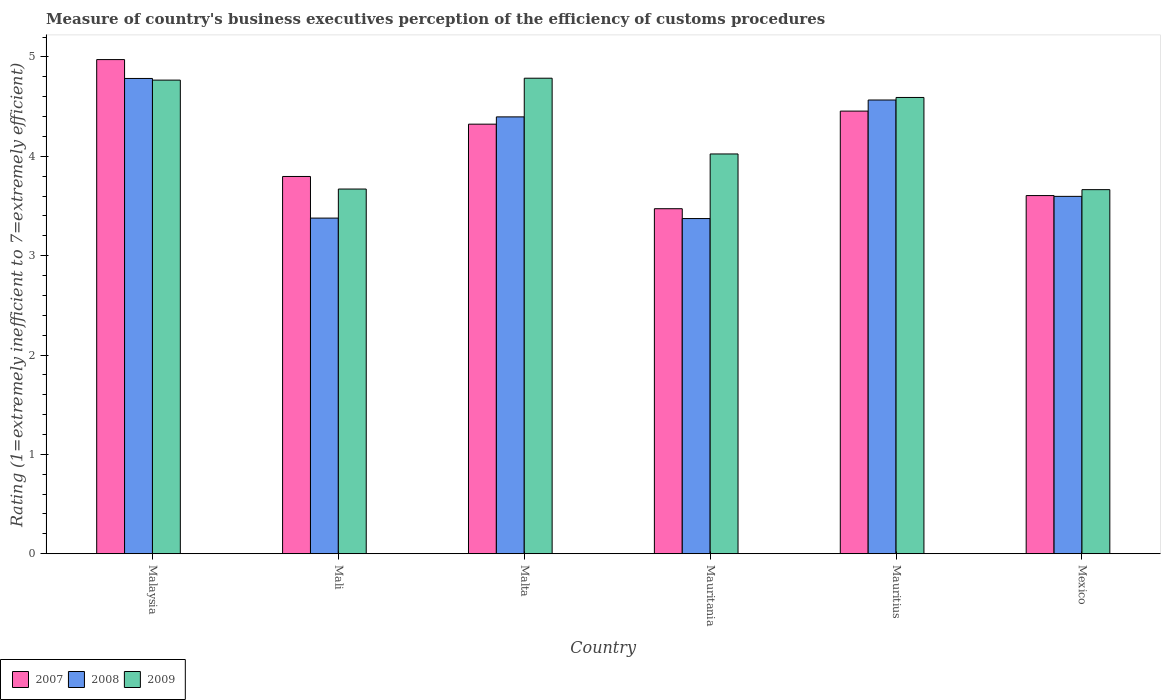How many different coloured bars are there?
Provide a succinct answer. 3. Are the number of bars per tick equal to the number of legend labels?
Your answer should be very brief. Yes. How many bars are there on the 3rd tick from the right?
Your answer should be very brief. 3. In how many cases, is the number of bars for a given country not equal to the number of legend labels?
Keep it short and to the point. 0. What is the rating of the efficiency of customs procedure in 2009 in Mali?
Your answer should be very brief. 3.67. Across all countries, what is the maximum rating of the efficiency of customs procedure in 2009?
Ensure brevity in your answer.  4.79. Across all countries, what is the minimum rating of the efficiency of customs procedure in 2009?
Keep it short and to the point. 3.66. In which country was the rating of the efficiency of customs procedure in 2009 maximum?
Make the answer very short. Malta. What is the total rating of the efficiency of customs procedure in 2009 in the graph?
Provide a succinct answer. 25.5. What is the difference between the rating of the efficiency of customs procedure in 2007 in Mali and that in Mauritania?
Ensure brevity in your answer.  0.32. What is the difference between the rating of the efficiency of customs procedure in 2007 in Malaysia and the rating of the efficiency of customs procedure in 2009 in Mauritius?
Your answer should be compact. 0.38. What is the average rating of the efficiency of customs procedure in 2007 per country?
Make the answer very short. 4.1. What is the difference between the rating of the efficiency of customs procedure of/in 2008 and rating of the efficiency of customs procedure of/in 2009 in Malaysia?
Your answer should be very brief. 0.02. What is the ratio of the rating of the efficiency of customs procedure in 2008 in Malaysia to that in Mexico?
Offer a terse response. 1.33. Is the difference between the rating of the efficiency of customs procedure in 2008 in Mauritania and Mauritius greater than the difference between the rating of the efficiency of customs procedure in 2009 in Mauritania and Mauritius?
Your answer should be compact. No. What is the difference between the highest and the second highest rating of the efficiency of customs procedure in 2008?
Provide a short and direct response. 0.22. What is the difference between the highest and the lowest rating of the efficiency of customs procedure in 2007?
Your response must be concise. 1.5. What does the 2nd bar from the right in Mauritius represents?
Your response must be concise. 2008. What is the difference between two consecutive major ticks on the Y-axis?
Ensure brevity in your answer.  1. Does the graph contain any zero values?
Make the answer very short. No. Does the graph contain grids?
Give a very brief answer. No. Where does the legend appear in the graph?
Provide a short and direct response. Bottom left. How many legend labels are there?
Offer a very short reply. 3. What is the title of the graph?
Make the answer very short. Measure of country's business executives perception of the efficiency of customs procedures. Does "2010" appear as one of the legend labels in the graph?
Keep it short and to the point. No. What is the label or title of the Y-axis?
Provide a short and direct response. Rating (1=extremely inefficient to 7=extremely efficient). What is the Rating (1=extremely inefficient to 7=extremely efficient) of 2007 in Malaysia?
Your response must be concise. 4.97. What is the Rating (1=extremely inefficient to 7=extremely efficient) in 2008 in Malaysia?
Your response must be concise. 4.78. What is the Rating (1=extremely inefficient to 7=extremely efficient) in 2009 in Malaysia?
Offer a terse response. 4.77. What is the Rating (1=extremely inefficient to 7=extremely efficient) in 2007 in Mali?
Your answer should be very brief. 3.8. What is the Rating (1=extremely inefficient to 7=extremely efficient) in 2008 in Mali?
Provide a short and direct response. 3.38. What is the Rating (1=extremely inefficient to 7=extremely efficient) in 2009 in Mali?
Keep it short and to the point. 3.67. What is the Rating (1=extremely inefficient to 7=extremely efficient) of 2007 in Malta?
Your answer should be compact. 4.32. What is the Rating (1=extremely inefficient to 7=extremely efficient) of 2008 in Malta?
Offer a terse response. 4.4. What is the Rating (1=extremely inefficient to 7=extremely efficient) of 2009 in Malta?
Your answer should be compact. 4.79. What is the Rating (1=extremely inefficient to 7=extremely efficient) of 2007 in Mauritania?
Your answer should be compact. 3.47. What is the Rating (1=extremely inefficient to 7=extremely efficient) in 2008 in Mauritania?
Make the answer very short. 3.37. What is the Rating (1=extremely inefficient to 7=extremely efficient) of 2009 in Mauritania?
Your answer should be compact. 4.02. What is the Rating (1=extremely inefficient to 7=extremely efficient) in 2007 in Mauritius?
Offer a very short reply. 4.45. What is the Rating (1=extremely inefficient to 7=extremely efficient) of 2008 in Mauritius?
Give a very brief answer. 4.57. What is the Rating (1=extremely inefficient to 7=extremely efficient) in 2009 in Mauritius?
Your answer should be very brief. 4.59. What is the Rating (1=extremely inefficient to 7=extremely efficient) in 2007 in Mexico?
Your response must be concise. 3.6. What is the Rating (1=extremely inefficient to 7=extremely efficient) of 2008 in Mexico?
Your answer should be very brief. 3.6. What is the Rating (1=extremely inefficient to 7=extremely efficient) of 2009 in Mexico?
Provide a short and direct response. 3.66. Across all countries, what is the maximum Rating (1=extremely inefficient to 7=extremely efficient) in 2007?
Ensure brevity in your answer.  4.97. Across all countries, what is the maximum Rating (1=extremely inefficient to 7=extremely efficient) in 2008?
Keep it short and to the point. 4.78. Across all countries, what is the maximum Rating (1=extremely inefficient to 7=extremely efficient) of 2009?
Provide a succinct answer. 4.79. Across all countries, what is the minimum Rating (1=extremely inefficient to 7=extremely efficient) of 2007?
Offer a terse response. 3.47. Across all countries, what is the minimum Rating (1=extremely inefficient to 7=extremely efficient) in 2008?
Offer a terse response. 3.37. Across all countries, what is the minimum Rating (1=extremely inefficient to 7=extremely efficient) in 2009?
Ensure brevity in your answer.  3.66. What is the total Rating (1=extremely inefficient to 7=extremely efficient) of 2007 in the graph?
Your answer should be compact. 24.62. What is the total Rating (1=extremely inefficient to 7=extremely efficient) of 2008 in the graph?
Keep it short and to the point. 24.09. What is the total Rating (1=extremely inefficient to 7=extremely efficient) of 2009 in the graph?
Ensure brevity in your answer.  25.5. What is the difference between the Rating (1=extremely inefficient to 7=extremely efficient) of 2007 in Malaysia and that in Mali?
Your answer should be very brief. 1.18. What is the difference between the Rating (1=extremely inefficient to 7=extremely efficient) in 2008 in Malaysia and that in Mali?
Provide a short and direct response. 1.41. What is the difference between the Rating (1=extremely inefficient to 7=extremely efficient) in 2009 in Malaysia and that in Mali?
Offer a terse response. 1.1. What is the difference between the Rating (1=extremely inefficient to 7=extremely efficient) of 2007 in Malaysia and that in Malta?
Your answer should be compact. 0.65. What is the difference between the Rating (1=extremely inefficient to 7=extremely efficient) in 2008 in Malaysia and that in Malta?
Offer a very short reply. 0.39. What is the difference between the Rating (1=extremely inefficient to 7=extremely efficient) of 2009 in Malaysia and that in Malta?
Provide a short and direct response. -0.02. What is the difference between the Rating (1=extremely inefficient to 7=extremely efficient) of 2007 in Malaysia and that in Mauritania?
Offer a very short reply. 1.5. What is the difference between the Rating (1=extremely inefficient to 7=extremely efficient) in 2008 in Malaysia and that in Mauritania?
Your response must be concise. 1.41. What is the difference between the Rating (1=extremely inefficient to 7=extremely efficient) of 2009 in Malaysia and that in Mauritania?
Ensure brevity in your answer.  0.74. What is the difference between the Rating (1=extremely inefficient to 7=extremely efficient) of 2007 in Malaysia and that in Mauritius?
Provide a succinct answer. 0.52. What is the difference between the Rating (1=extremely inefficient to 7=extremely efficient) in 2008 in Malaysia and that in Mauritius?
Provide a short and direct response. 0.22. What is the difference between the Rating (1=extremely inefficient to 7=extremely efficient) in 2009 in Malaysia and that in Mauritius?
Offer a terse response. 0.17. What is the difference between the Rating (1=extremely inefficient to 7=extremely efficient) in 2007 in Malaysia and that in Mexico?
Provide a short and direct response. 1.37. What is the difference between the Rating (1=extremely inefficient to 7=extremely efficient) of 2008 in Malaysia and that in Mexico?
Provide a succinct answer. 1.19. What is the difference between the Rating (1=extremely inefficient to 7=extremely efficient) in 2009 in Malaysia and that in Mexico?
Offer a very short reply. 1.1. What is the difference between the Rating (1=extremely inefficient to 7=extremely efficient) of 2007 in Mali and that in Malta?
Keep it short and to the point. -0.53. What is the difference between the Rating (1=extremely inefficient to 7=extremely efficient) of 2008 in Mali and that in Malta?
Offer a very short reply. -1.02. What is the difference between the Rating (1=extremely inefficient to 7=extremely efficient) of 2009 in Mali and that in Malta?
Offer a very short reply. -1.12. What is the difference between the Rating (1=extremely inefficient to 7=extremely efficient) of 2007 in Mali and that in Mauritania?
Offer a very short reply. 0.32. What is the difference between the Rating (1=extremely inefficient to 7=extremely efficient) of 2008 in Mali and that in Mauritania?
Provide a short and direct response. 0. What is the difference between the Rating (1=extremely inefficient to 7=extremely efficient) of 2009 in Mali and that in Mauritania?
Your answer should be compact. -0.35. What is the difference between the Rating (1=extremely inefficient to 7=extremely efficient) in 2007 in Mali and that in Mauritius?
Your response must be concise. -0.66. What is the difference between the Rating (1=extremely inefficient to 7=extremely efficient) of 2008 in Mali and that in Mauritius?
Make the answer very short. -1.19. What is the difference between the Rating (1=extremely inefficient to 7=extremely efficient) in 2009 in Mali and that in Mauritius?
Provide a succinct answer. -0.92. What is the difference between the Rating (1=extremely inefficient to 7=extremely efficient) in 2007 in Mali and that in Mexico?
Your response must be concise. 0.19. What is the difference between the Rating (1=extremely inefficient to 7=extremely efficient) of 2008 in Mali and that in Mexico?
Give a very brief answer. -0.22. What is the difference between the Rating (1=extremely inefficient to 7=extremely efficient) in 2009 in Mali and that in Mexico?
Provide a succinct answer. 0.01. What is the difference between the Rating (1=extremely inefficient to 7=extremely efficient) of 2007 in Malta and that in Mauritania?
Ensure brevity in your answer.  0.85. What is the difference between the Rating (1=extremely inefficient to 7=extremely efficient) in 2008 in Malta and that in Mauritania?
Your answer should be compact. 1.02. What is the difference between the Rating (1=extremely inefficient to 7=extremely efficient) of 2009 in Malta and that in Mauritania?
Provide a succinct answer. 0.76. What is the difference between the Rating (1=extremely inefficient to 7=extremely efficient) in 2007 in Malta and that in Mauritius?
Give a very brief answer. -0.13. What is the difference between the Rating (1=extremely inefficient to 7=extremely efficient) of 2008 in Malta and that in Mauritius?
Your answer should be compact. -0.17. What is the difference between the Rating (1=extremely inefficient to 7=extremely efficient) of 2009 in Malta and that in Mauritius?
Provide a succinct answer. 0.19. What is the difference between the Rating (1=extremely inefficient to 7=extremely efficient) of 2007 in Malta and that in Mexico?
Make the answer very short. 0.72. What is the difference between the Rating (1=extremely inefficient to 7=extremely efficient) in 2008 in Malta and that in Mexico?
Make the answer very short. 0.8. What is the difference between the Rating (1=extremely inefficient to 7=extremely efficient) in 2009 in Malta and that in Mexico?
Offer a very short reply. 1.12. What is the difference between the Rating (1=extremely inefficient to 7=extremely efficient) in 2007 in Mauritania and that in Mauritius?
Offer a terse response. -0.98. What is the difference between the Rating (1=extremely inefficient to 7=extremely efficient) in 2008 in Mauritania and that in Mauritius?
Offer a terse response. -1.19. What is the difference between the Rating (1=extremely inefficient to 7=extremely efficient) in 2009 in Mauritania and that in Mauritius?
Keep it short and to the point. -0.57. What is the difference between the Rating (1=extremely inefficient to 7=extremely efficient) in 2007 in Mauritania and that in Mexico?
Provide a succinct answer. -0.13. What is the difference between the Rating (1=extremely inefficient to 7=extremely efficient) in 2008 in Mauritania and that in Mexico?
Your response must be concise. -0.22. What is the difference between the Rating (1=extremely inefficient to 7=extremely efficient) of 2009 in Mauritania and that in Mexico?
Provide a short and direct response. 0.36. What is the difference between the Rating (1=extremely inefficient to 7=extremely efficient) in 2007 in Mauritius and that in Mexico?
Keep it short and to the point. 0.85. What is the difference between the Rating (1=extremely inefficient to 7=extremely efficient) of 2008 in Mauritius and that in Mexico?
Offer a terse response. 0.97. What is the difference between the Rating (1=extremely inefficient to 7=extremely efficient) of 2009 in Mauritius and that in Mexico?
Make the answer very short. 0.93. What is the difference between the Rating (1=extremely inefficient to 7=extremely efficient) of 2007 in Malaysia and the Rating (1=extremely inefficient to 7=extremely efficient) of 2008 in Mali?
Offer a terse response. 1.6. What is the difference between the Rating (1=extremely inefficient to 7=extremely efficient) of 2007 in Malaysia and the Rating (1=extremely inefficient to 7=extremely efficient) of 2009 in Mali?
Your response must be concise. 1.3. What is the difference between the Rating (1=extremely inefficient to 7=extremely efficient) of 2008 in Malaysia and the Rating (1=extremely inefficient to 7=extremely efficient) of 2009 in Mali?
Your answer should be compact. 1.11. What is the difference between the Rating (1=extremely inefficient to 7=extremely efficient) of 2007 in Malaysia and the Rating (1=extremely inefficient to 7=extremely efficient) of 2008 in Malta?
Provide a short and direct response. 0.58. What is the difference between the Rating (1=extremely inefficient to 7=extremely efficient) of 2007 in Malaysia and the Rating (1=extremely inefficient to 7=extremely efficient) of 2009 in Malta?
Keep it short and to the point. 0.19. What is the difference between the Rating (1=extremely inefficient to 7=extremely efficient) in 2008 in Malaysia and the Rating (1=extremely inefficient to 7=extremely efficient) in 2009 in Malta?
Make the answer very short. -0. What is the difference between the Rating (1=extremely inefficient to 7=extremely efficient) of 2007 in Malaysia and the Rating (1=extremely inefficient to 7=extremely efficient) of 2008 in Mauritania?
Keep it short and to the point. 1.6. What is the difference between the Rating (1=extremely inefficient to 7=extremely efficient) of 2007 in Malaysia and the Rating (1=extremely inefficient to 7=extremely efficient) of 2009 in Mauritania?
Make the answer very short. 0.95. What is the difference between the Rating (1=extremely inefficient to 7=extremely efficient) in 2008 in Malaysia and the Rating (1=extremely inefficient to 7=extremely efficient) in 2009 in Mauritania?
Your answer should be very brief. 0.76. What is the difference between the Rating (1=extremely inefficient to 7=extremely efficient) of 2007 in Malaysia and the Rating (1=extremely inefficient to 7=extremely efficient) of 2008 in Mauritius?
Keep it short and to the point. 0.41. What is the difference between the Rating (1=extremely inefficient to 7=extremely efficient) in 2007 in Malaysia and the Rating (1=extremely inefficient to 7=extremely efficient) in 2009 in Mauritius?
Give a very brief answer. 0.38. What is the difference between the Rating (1=extremely inefficient to 7=extremely efficient) of 2008 in Malaysia and the Rating (1=extremely inefficient to 7=extremely efficient) of 2009 in Mauritius?
Keep it short and to the point. 0.19. What is the difference between the Rating (1=extremely inefficient to 7=extremely efficient) of 2007 in Malaysia and the Rating (1=extremely inefficient to 7=extremely efficient) of 2008 in Mexico?
Give a very brief answer. 1.38. What is the difference between the Rating (1=extremely inefficient to 7=extremely efficient) of 2007 in Malaysia and the Rating (1=extremely inefficient to 7=extremely efficient) of 2009 in Mexico?
Make the answer very short. 1.31. What is the difference between the Rating (1=extremely inefficient to 7=extremely efficient) in 2008 in Malaysia and the Rating (1=extremely inefficient to 7=extremely efficient) in 2009 in Mexico?
Keep it short and to the point. 1.12. What is the difference between the Rating (1=extremely inefficient to 7=extremely efficient) in 2007 in Mali and the Rating (1=extremely inefficient to 7=extremely efficient) in 2008 in Malta?
Offer a terse response. -0.6. What is the difference between the Rating (1=extremely inefficient to 7=extremely efficient) of 2007 in Mali and the Rating (1=extremely inefficient to 7=extremely efficient) of 2009 in Malta?
Keep it short and to the point. -0.99. What is the difference between the Rating (1=extremely inefficient to 7=extremely efficient) in 2008 in Mali and the Rating (1=extremely inefficient to 7=extremely efficient) in 2009 in Malta?
Provide a succinct answer. -1.41. What is the difference between the Rating (1=extremely inefficient to 7=extremely efficient) in 2007 in Mali and the Rating (1=extremely inefficient to 7=extremely efficient) in 2008 in Mauritania?
Offer a terse response. 0.42. What is the difference between the Rating (1=extremely inefficient to 7=extremely efficient) in 2007 in Mali and the Rating (1=extremely inefficient to 7=extremely efficient) in 2009 in Mauritania?
Offer a terse response. -0.23. What is the difference between the Rating (1=extremely inefficient to 7=extremely efficient) in 2008 in Mali and the Rating (1=extremely inefficient to 7=extremely efficient) in 2009 in Mauritania?
Offer a terse response. -0.65. What is the difference between the Rating (1=extremely inefficient to 7=extremely efficient) in 2007 in Mali and the Rating (1=extremely inefficient to 7=extremely efficient) in 2008 in Mauritius?
Provide a short and direct response. -0.77. What is the difference between the Rating (1=extremely inefficient to 7=extremely efficient) of 2007 in Mali and the Rating (1=extremely inefficient to 7=extremely efficient) of 2009 in Mauritius?
Make the answer very short. -0.8. What is the difference between the Rating (1=extremely inefficient to 7=extremely efficient) of 2008 in Mali and the Rating (1=extremely inefficient to 7=extremely efficient) of 2009 in Mauritius?
Make the answer very short. -1.21. What is the difference between the Rating (1=extremely inefficient to 7=extremely efficient) of 2007 in Mali and the Rating (1=extremely inefficient to 7=extremely efficient) of 2008 in Mexico?
Offer a very short reply. 0.2. What is the difference between the Rating (1=extremely inefficient to 7=extremely efficient) in 2007 in Mali and the Rating (1=extremely inefficient to 7=extremely efficient) in 2009 in Mexico?
Keep it short and to the point. 0.13. What is the difference between the Rating (1=extremely inefficient to 7=extremely efficient) in 2008 in Mali and the Rating (1=extremely inefficient to 7=extremely efficient) in 2009 in Mexico?
Your answer should be compact. -0.29. What is the difference between the Rating (1=extremely inefficient to 7=extremely efficient) in 2007 in Malta and the Rating (1=extremely inefficient to 7=extremely efficient) in 2008 in Mauritania?
Your answer should be compact. 0.95. What is the difference between the Rating (1=extremely inefficient to 7=extremely efficient) in 2007 in Malta and the Rating (1=extremely inefficient to 7=extremely efficient) in 2009 in Mauritania?
Offer a very short reply. 0.3. What is the difference between the Rating (1=extremely inefficient to 7=extremely efficient) in 2008 in Malta and the Rating (1=extremely inefficient to 7=extremely efficient) in 2009 in Mauritania?
Give a very brief answer. 0.37. What is the difference between the Rating (1=extremely inefficient to 7=extremely efficient) in 2007 in Malta and the Rating (1=extremely inefficient to 7=extremely efficient) in 2008 in Mauritius?
Your answer should be compact. -0.24. What is the difference between the Rating (1=extremely inefficient to 7=extremely efficient) of 2007 in Malta and the Rating (1=extremely inefficient to 7=extremely efficient) of 2009 in Mauritius?
Make the answer very short. -0.27. What is the difference between the Rating (1=extremely inefficient to 7=extremely efficient) of 2008 in Malta and the Rating (1=extremely inefficient to 7=extremely efficient) of 2009 in Mauritius?
Your answer should be compact. -0.2. What is the difference between the Rating (1=extremely inefficient to 7=extremely efficient) in 2007 in Malta and the Rating (1=extremely inefficient to 7=extremely efficient) in 2008 in Mexico?
Offer a very short reply. 0.73. What is the difference between the Rating (1=extremely inefficient to 7=extremely efficient) in 2007 in Malta and the Rating (1=extremely inefficient to 7=extremely efficient) in 2009 in Mexico?
Offer a very short reply. 0.66. What is the difference between the Rating (1=extremely inefficient to 7=extremely efficient) in 2008 in Malta and the Rating (1=extremely inefficient to 7=extremely efficient) in 2009 in Mexico?
Provide a succinct answer. 0.73. What is the difference between the Rating (1=extremely inefficient to 7=extremely efficient) of 2007 in Mauritania and the Rating (1=extremely inefficient to 7=extremely efficient) of 2008 in Mauritius?
Keep it short and to the point. -1.09. What is the difference between the Rating (1=extremely inefficient to 7=extremely efficient) in 2007 in Mauritania and the Rating (1=extremely inefficient to 7=extremely efficient) in 2009 in Mauritius?
Offer a very short reply. -1.12. What is the difference between the Rating (1=extremely inefficient to 7=extremely efficient) of 2008 in Mauritania and the Rating (1=extremely inefficient to 7=extremely efficient) of 2009 in Mauritius?
Your response must be concise. -1.22. What is the difference between the Rating (1=extremely inefficient to 7=extremely efficient) of 2007 in Mauritania and the Rating (1=extremely inefficient to 7=extremely efficient) of 2008 in Mexico?
Keep it short and to the point. -0.12. What is the difference between the Rating (1=extremely inefficient to 7=extremely efficient) in 2007 in Mauritania and the Rating (1=extremely inefficient to 7=extremely efficient) in 2009 in Mexico?
Ensure brevity in your answer.  -0.19. What is the difference between the Rating (1=extremely inefficient to 7=extremely efficient) of 2008 in Mauritania and the Rating (1=extremely inefficient to 7=extremely efficient) of 2009 in Mexico?
Your response must be concise. -0.29. What is the difference between the Rating (1=extremely inefficient to 7=extremely efficient) of 2007 in Mauritius and the Rating (1=extremely inefficient to 7=extremely efficient) of 2008 in Mexico?
Offer a terse response. 0.86. What is the difference between the Rating (1=extremely inefficient to 7=extremely efficient) of 2007 in Mauritius and the Rating (1=extremely inefficient to 7=extremely efficient) of 2009 in Mexico?
Offer a very short reply. 0.79. What is the difference between the Rating (1=extremely inefficient to 7=extremely efficient) of 2008 in Mauritius and the Rating (1=extremely inefficient to 7=extremely efficient) of 2009 in Mexico?
Make the answer very short. 0.9. What is the average Rating (1=extremely inefficient to 7=extremely efficient) in 2007 per country?
Offer a terse response. 4.1. What is the average Rating (1=extremely inefficient to 7=extremely efficient) in 2008 per country?
Make the answer very short. 4.02. What is the average Rating (1=extremely inefficient to 7=extremely efficient) in 2009 per country?
Keep it short and to the point. 4.25. What is the difference between the Rating (1=extremely inefficient to 7=extremely efficient) of 2007 and Rating (1=extremely inefficient to 7=extremely efficient) of 2008 in Malaysia?
Your answer should be compact. 0.19. What is the difference between the Rating (1=extremely inefficient to 7=extremely efficient) of 2007 and Rating (1=extremely inefficient to 7=extremely efficient) of 2009 in Malaysia?
Keep it short and to the point. 0.21. What is the difference between the Rating (1=extremely inefficient to 7=extremely efficient) of 2008 and Rating (1=extremely inefficient to 7=extremely efficient) of 2009 in Malaysia?
Your answer should be very brief. 0.02. What is the difference between the Rating (1=extremely inefficient to 7=extremely efficient) in 2007 and Rating (1=extremely inefficient to 7=extremely efficient) in 2008 in Mali?
Your answer should be compact. 0.42. What is the difference between the Rating (1=extremely inefficient to 7=extremely efficient) of 2007 and Rating (1=extremely inefficient to 7=extremely efficient) of 2009 in Mali?
Keep it short and to the point. 0.13. What is the difference between the Rating (1=extremely inefficient to 7=extremely efficient) in 2008 and Rating (1=extremely inefficient to 7=extremely efficient) in 2009 in Mali?
Your answer should be compact. -0.29. What is the difference between the Rating (1=extremely inefficient to 7=extremely efficient) in 2007 and Rating (1=extremely inefficient to 7=extremely efficient) in 2008 in Malta?
Provide a short and direct response. -0.07. What is the difference between the Rating (1=extremely inefficient to 7=extremely efficient) in 2007 and Rating (1=extremely inefficient to 7=extremely efficient) in 2009 in Malta?
Ensure brevity in your answer.  -0.46. What is the difference between the Rating (1=extremely inefficient to 7=extremely efficient) of 2008 and Rating (1=extremely inefficient to 7=extremely efficient) of 2009 in Malta?
Keep it short and to the point. -0.39. What is the difference between the Rating (1=extremely inefficient to 7=extremely efficient) of 2007 and Rating (1=extremely inefficient to 7=extremely efficient) of 2008 in Mauritania?
Make the answer very short. 0.1. What is the difference between the Rating (1=extremely inefficient to 7=extremely efficient) of 2007 and Rating (1=extremely inefficient to 7=extremely efficient) of 2009 in Mauritania?
Your answer should be compact. -0.55. What is the difference between the Rating (1=extremely inefficient to 7=extremely efficient) in 2008 and Rating (1=extremely inefficient to 7=extremely efficient) in 2009 in Mauritania?
Provide a succinct answer. -0.65. What is the difference between the Rating (1=extremely inefficient to 7=extremely efficient) in 2007 and Rating (1=extremely inefficient to 7=extremely efficient) in 2008 in Mauritius?
Your answer should be compact. -0.11. What is the difference between the Rating (1=extremely inefficient to 7=extremely efficient) of 2007 and Rating (1=extremely inefficient to 7=extremely efficient) of 2009 in Mauritius?
Provide a short and direct response. -0.14. What is the difference between the Rating (1=extremely inefficient to 7=extremely efficient) of 2008 and Rating (1=extremely inefficient to 7=extremely efficient) of 2009 in Mauritius?
Keep it short and to the point. -0.03. What is the difference between the Rating (1=extremely inefficient to 7=extremely efficient) of 2007 and Rating (1=extremely inefficient to 7=extremely efficient) of 2008 in Mexico?
Keep it short and to the point. 0.01. What is the difference between the Rating (1=extremely inefficient to 7=extremely efficient) in 2007 and Rating (1=extremely inefficient to 7=extremely efficient) in 2009 in Mexico?
Ensure brevity in your answer.  -0.06. What is the difference between the Rating (1=extremely inefficient to 7=extremely efficient) of 2008 and Rating (1=extremely inefficient to 7=extremely efficient) of 2009 in Mexico?
Your answer should be compact. -0.07. What is the ratio of the Rating (1=extremely inefficient to 7=extremely efficient) in 2007 in Malaysia to that in Mali?
Offer a very short reply. 1.31. What is the ratio of the Rating (1=extremely inefficient to 7=extremely efficient) in 2008 in Malaysia to that in Mali?
Ensure brevity in your answer.  1.42. What is the ratio of the Rating (1=extremely inefficient to 7=extremely efficient) in 2009 in Malaysia to that in Mali?
Provide a succinct answer. 1.3. What is the ratio of the Rating (1=extremely inefficient to 7=extremely efficient) of 2007 in Malaysia to that in Malta?
Your answer should be very brief. 1.15. What is the ratio of the Rating (1=extremely inefficient to 7=extremely efficient) of 2008 in Malaysia to that in Malta?
Provide a short and direct response. 1.09. What is the ratio of the Rating (1=extremely inefficient to 7=extremely efficient) of 2007 in Malaysia to that in Mauritania?
Your answer should be compact. 1.43. What is the ratio of the Rating (1=extremely inefficient to 7=extremely efficient) of 2008 in Malaysia to that in Mauritania?
Provide a succinct answer. 1.42. What is the ratio of the Rating (1=extremely inefficient to 7=extremely efficient) of 2009 in Malaysia to that in Mauritania?
Offer a terse response. 1.18. What is the ratio of the Rating (1=extremely inefficient to 7=extremely efficient) of 2007 in Malaysia to that in Mauritius?
Offer a terse response. 1.12. What is the ratio of the Rating (1=extremely inefficient to 7=extremely efficient) in 2008 in Malaysia to that in Mauritius?
Give a very brief answer. 1.05. What is the ratio of the Rating (1=extremely inefficient to 7=extremely efficient) of 2009 in Malaysia to that in Mauritius?
Provide a succinct answer. 1.04. What is the ratio of the Rating (1=extremely inefficient to 7=extremely efficient) of 2007 in Malaysia to that in Mexico?
Offer a very short reply. 1.38. What is the ratio of the Rating (1=extremely inefficient to 7=extremely efficient) of 2008 in Malaysia to that in Mexico?
Keep it short and to the point. 1.33. What is the ratio of the Rating (1=extremely inefficient to 7=extremely efficient) in 2009 in Malaysia to that in Mexico?
Provide a short and direct response. 1.3. What is the ratio of the Rating (1=extremely inefficient to 7=extremely efficient) in 2007 in Mali to that in Malta?
Make the answer very short. 0.88. What is the ratio of the Rating (1=extremely inefficient to 7=extremely efficient) of 2008 in Mali to that in Malta?
Give a very brief answer. 0.77. What is the ratio of the Rating (1=extremely inefficient to 7=extremely efficient) in 2009 in Mali to that in Malta?
Offer a terse response. 0.77. What is the ratio of the Rating (1=extremely inefficient to 7=extremely efficient) in 2007 in Mali to that in Mauritania?
Give a very brief answer. 1.09. What is the ratio of the Rating (1=extremely inefficient to 7=extremely efficient) in 2008 in Mali to that in Mauritania?
Your response must be concise. 1. What is the ratio of the Rating (1=extremely inefficient to 7=extremely efficient) of 2009 in Mali to that in Mauritania?
Ensure brevity in your answer.  0.91. What is the ratio of the Rating (1=extremely inefficient to 7=extremely efficient) of 2007 in Mali to that in Mauritius?
Your response must be concise. 0.85. What is the ratio of the Rating (1=extremely inefficient to 7=extremely efficient) in 2008 in Mali to that in Mauritius?
Make the answer very short. 0.74. What is the ratio of the Rating (1=extremely inefficient to 7=extremely efficient) in 2009 in Mali to that in Mauritius?
Make the answer very short. 0.8. What is the ratio of the Rating (1=extremely inefficient to 7=extremely efficient) of 2007 in Mali to that in Mexico?
Provide a short and direct response. 1.05. What is the ratio of the Rating (1=extremely inefficient to 7=extremely efficient) in 2008 in Mali to that in Mexico?
Ensure brevity in your answer.  0.94. What is the ratio of the Rating (1=extremely inefficient to 7=extremely efficient) in 2007 in Malta to that in Mauritania?
Your answer should be compact. 1.25. What is the ratio of the Rating (1=extremely inefficient to 7=extremely efficient) in 2008 in Malta to that in Mauritania?
Provide a succinct answer. 1.3. What is the ratio of the Rating (1=extremely inefficient to 7=extremely efficient) in 2009 in Malta to that in Mauritania?
Your answer should be compact. 1.19. What is the ratio of the Rating (1=extremely inefficient to 7=extremely efficient) of 2007 in Malta to that in Mauritius?
Ensure brevity in your answer.  0.97. What is the ratio of the Rating (1=extremely inefficient to 7=extremely efficient) in 2008 in Malta to that in Mauritius?
Your answer should be compact. 0.96. What is the ratio of the Rating (1=extremely inefficient to 7=extremely efficient) of 2009 in Malta to that in Mauritius?
Your response must be concise. 1.04. What is the ratio of the Rating (1=extremely inefficient to 7=extremely efficient) of 2007 in Malta to that in Mexico?
Keep it short and to the point. 1.2. What is the ratio of the Rating (1=extremely inefficient to 7=extremely efficient) in 2008 in Malta to that in Mexico?
Give a very brief answer. 1.22. What is the ratio of the Rating (1=extremely inefficient to 7=extremely efficient) in 2009 in Malta to that in Mexico?
Offer a terse response. 1.31. What is the ratio of the Rating (1=extremely inefficient to 7=extremely efficient) of 2007 in Mauritania to that in Mauritius?
Make the answer very short. 0.78. What is the ratio of the Rating (1=extremely inefficient to 7=extremely efficient) of 2008 in Mauritania to that in Mauritius?
Ensure brevity in your answer.  0.74. What is the ratio of the Rating (1=extremely inefficient to 7=extremely efficient) of 2009 in Mauritania to that in Mauritius?
Provide a short and direct response. 0.88. What is the ratio of the Rating (1=extremely inefficient to 7=extremely efficient) in 2007 in Mauritania to that in Mexico?
Offer a very short reply. 0.96. What is the ratio of the Rating (1=extremely inefficient to 7=extremely efficient) in 2008 in Mauritania to that in Mexico?
Your answer should be compact. 0.94. What is the ratio of the Rating (1=extremely inefficient to 7=extremely efficient) of 2009 in Mauritania to that in Mexico?
Offer a very short reply. 1.1. What is the ratio of the Rating (1=extremely inefficient to 7=extremely efficient) in 2007 in Mauritius to that in Mexico?
Your response must be concise. 1.24. What is the ratio of the Rating (1=extremely inefficient to 7=extremely efficient) in 2008 in Mauritius to that in Mexico?
Ensure brevity in your answer.  1.27. What is the ratio of the Rating (1=extremely inefficient to 7=extremely efficient) in 2009 in Mauritius to that in Mexico?
Give a very brief answer. 1.25. What is the difference between the highest and the second highest Rating (1=extremely inefficient to 7=extremely efficient) of 2007?
Give a very brief answer. 0.52. What is the difference between the highest and the second highest Rating (1=extremely inefficient to 7=extremely efficient) of 2008?
Give a very brief answer. 0.22. What is the difference between the highest and the second highest Rating (1=extremely inefficient to 7=extremely efficient) in 2009?
Make the answer very short. 0.02. What is the difference between the highest and the lowest Rating (1=extremely inefficient to 7=extremely efficient) of 2007?
Your response must be concise. 1.5. What is the difference between the highest and the lowest Rating (1=extremely inefficient to 7=extremely efficient) in 2008?
Your answer should be compact. 1.41. What is the difference between the highest and the lowest Rating (1=extremely inefficient to 7=extremely efficient) in 2009?
Ensure brevity in your answer.  1.12. 